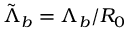<formula> <loc_0><loc_0><loc_500><loc_500>\tilde { \Lambda } _ { b } = \Lambda _ { b } / R _ { 0 }</formula> 